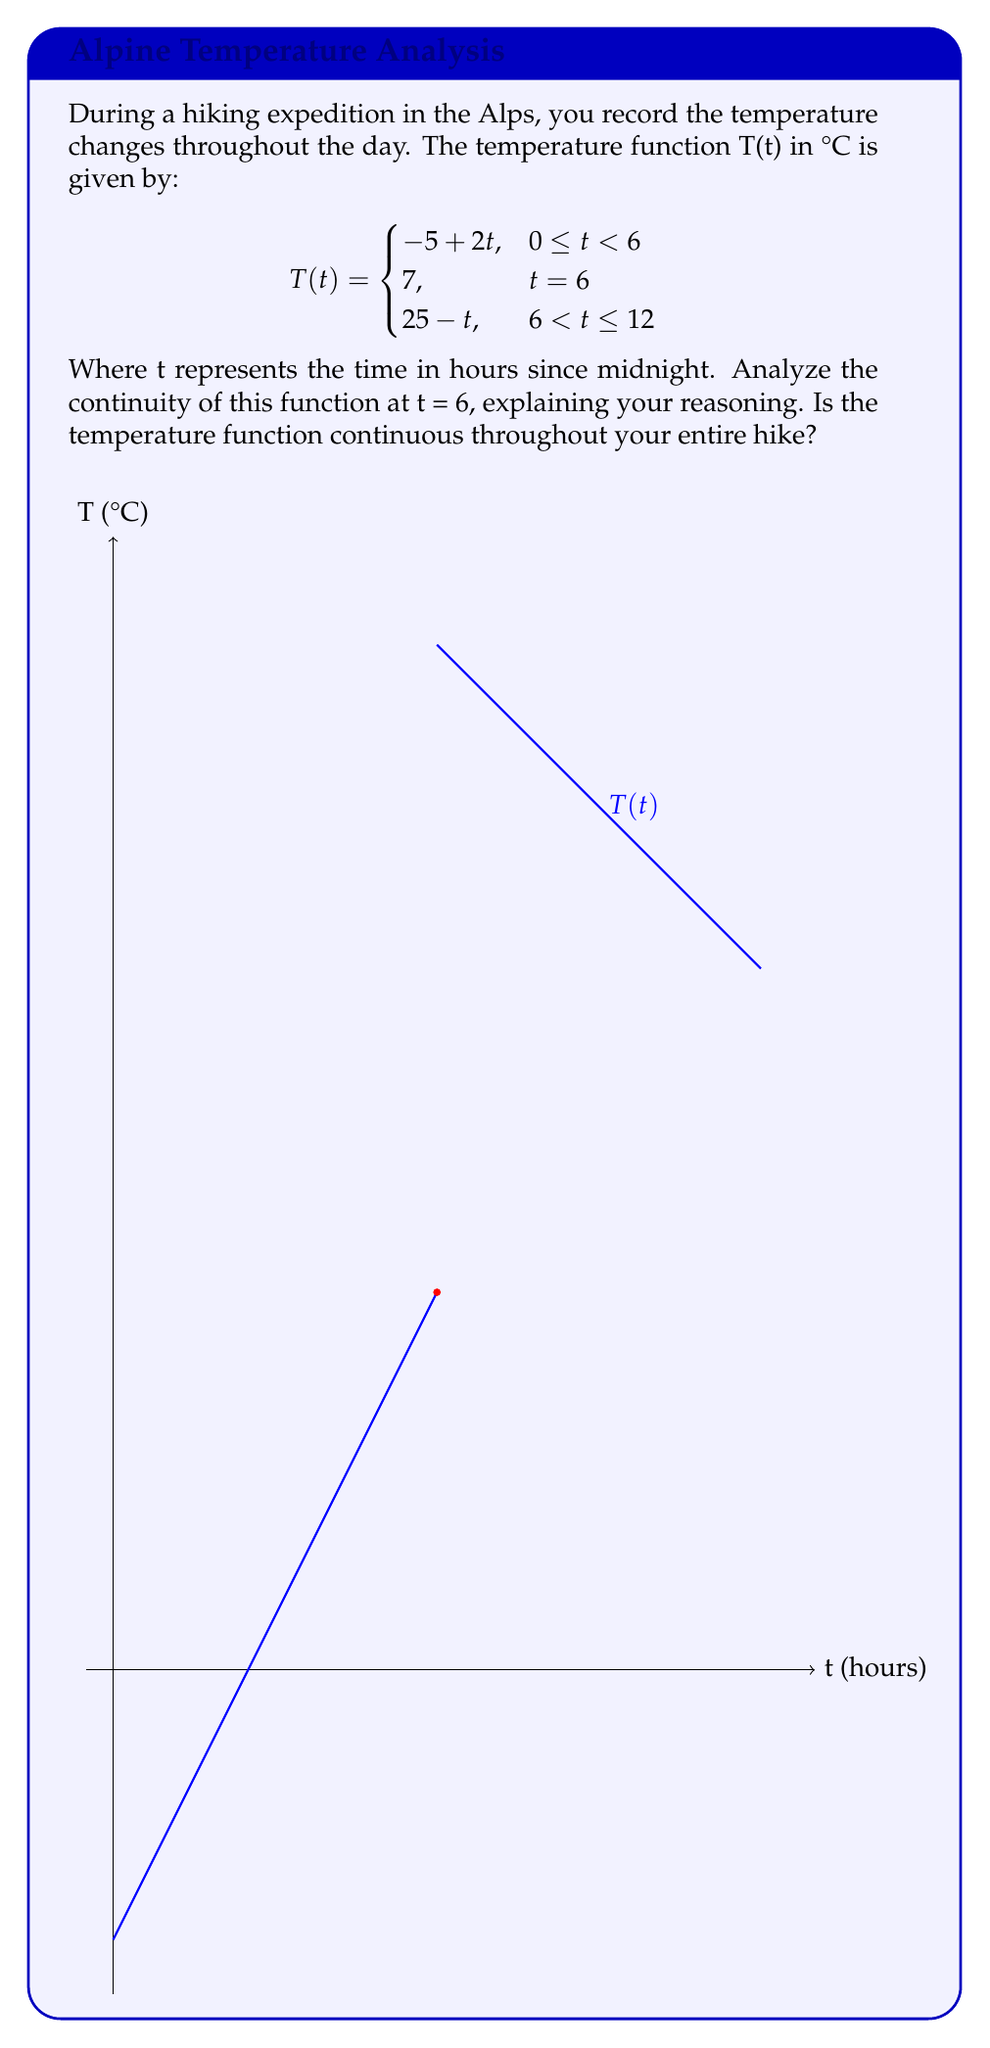Teach me how to tackle this problem. To analyze the continuity of the function T(t) at t = 6, we need to check three conditions:

1. The function must be defined at t = 6.
2. The limit of the function as t approaches 6 from the left must exist.
3. The limit of the function as t approaches 6 from the right must exist.
4. Both one-sided limits and the function value at t = 6 must be equal.

Let's check each condition:

1. T(6) = 7, so the function is defined at t = 6.

2. Left-hand limit:
   $$\lim_{t \to 6^-} T(t) = \lim_{t \to 6^-} (-5 + 2t) = -5 + 2(6) = 7$$

3. Right-hand limit:
   $$\lim_{t \to 6^+} T(t) = \lim_{t \to 6^+} (25 - t) = 25 - 6 = 19$$

4. Comparing the limits and function value:
   Left-hand limit = 7
   Right-hand limit = 19
   T(6) = 7

We can see that while the left-hand limit equals T(6), the right-hand limit does not. Therefore, the function is not continuous at t = 6.

To determine if the function is continuous throughout the entire hike, we need to check its continuity on the intervals [0,6) and (6,12]:

- On [0,6), T(t) = -5 + 2t is a linear function, which is continuous.
- On (6,12], T(t) = 25 - t is also a linear function, which is continuous.

However, due to the discontinuity at t = 6, the function is not continuous throughout the entire hike.
Answer: The function is discontinuous at t = 6 and not continuous throughout the entire hike. 